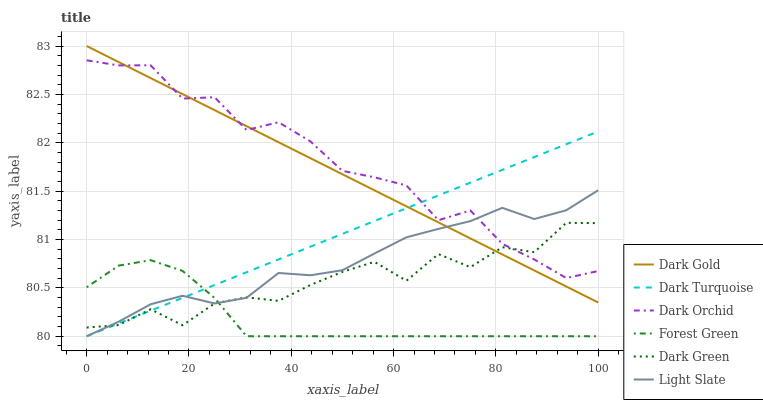Does Forest Green have the minimum area under the curve?
Answer yes or no. Yes. Does Dark Orchid have the maximum area under the curve?
Answer yes or no. Yes. Does Light Slate have the minimum area under the curve?
Answer yes or no. No. Does Light Slate have the maximum area under the curve?
Answer yes or no. No. Is Dark Turquoise the smoothest?
Answer yes or no. Yes. Is Dark Orchid the roughest?
Answer yes or no. Yes. Is Light Slate the smoothest?
Answer yes or no. No. Is Light Slate the roughest?
Answer yes or no. No. Does Light Slate have the lowest value?
Answer yes or no. Yes. Does Dark Orchid have the lowest value?
Answer yes or no. No. Does Dark Gold have the highest value?
Answer yes or no. Yes. Does Light Slate have the highest value?
Answer yes or no. No. Is Forest Green less than Dark Orchid?
Answer yes or no. Yes. Is Dark Gold greater than Forest Green?
Answer yes or no. Yes. Does Dark Turquoise intersect Dark Green?
Answer yes or no. Yes. Is Dark Turquoise less than Dark Green?
Answer yes or no. No. Is Dark Turquoise greater than Dark Green?
Answer yes or no. No. Does Forest Green intersect Dark Orchid?
Answer yes or no. No. 